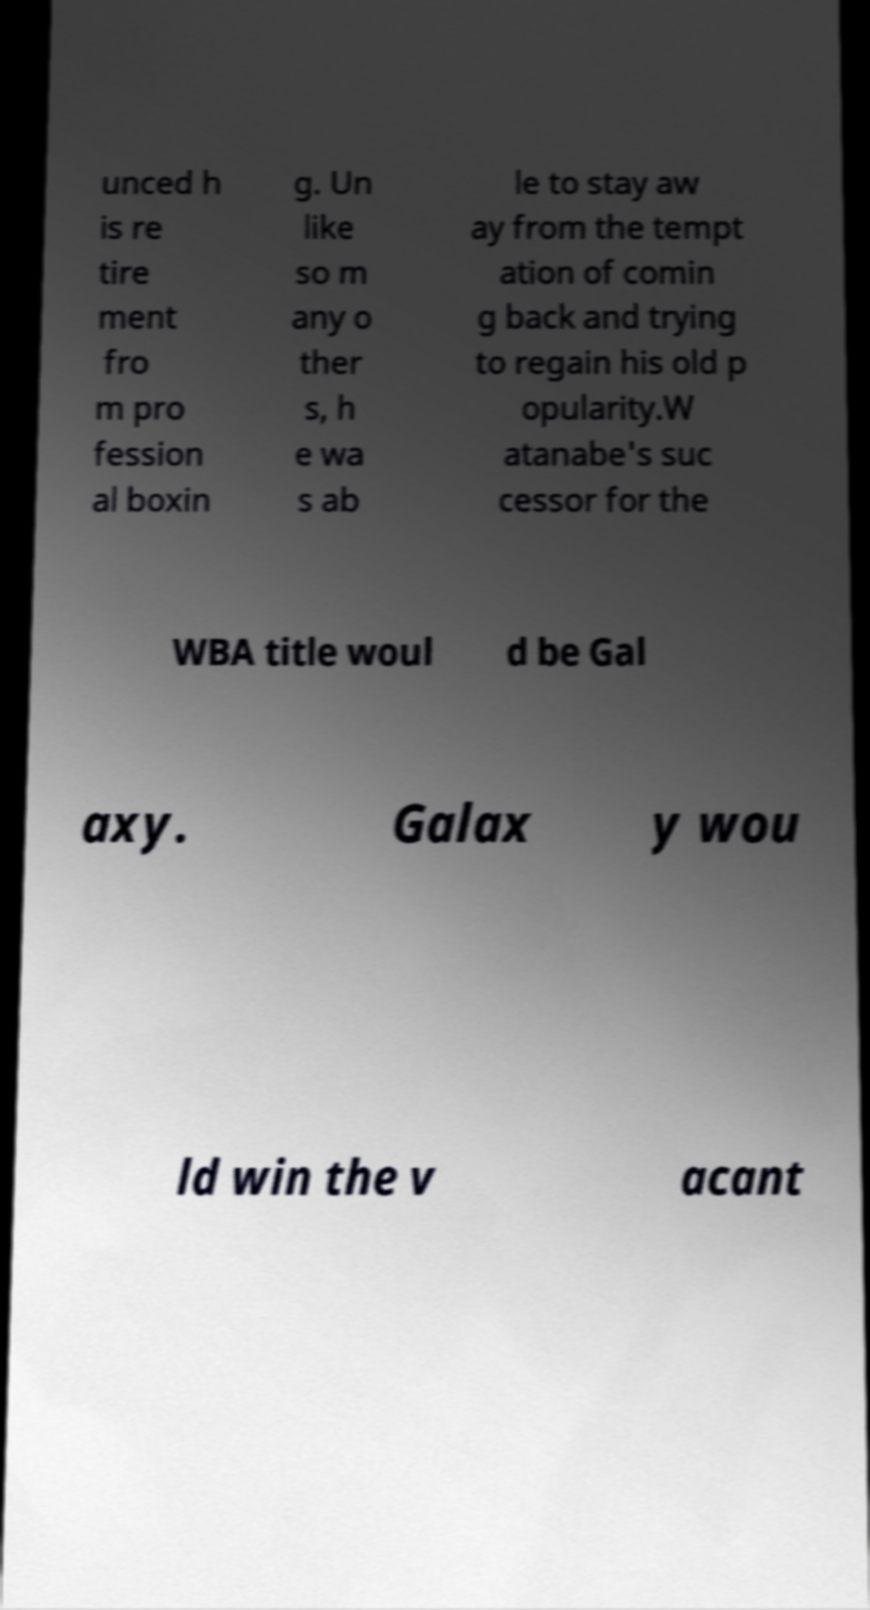What messages or text are displayed in this image? I need them in a readable, typed format. unced h is re tire ment fro m pro fession al boxin g. Un like so m any o ther s, h e wa s ab le to stay aw ay from the tempt ation of comin g back and trying to regain his old p opularity.W atanabe's suc cessor for the WBA title woul d be Gal axy. Galax y wou ld win the v acant 